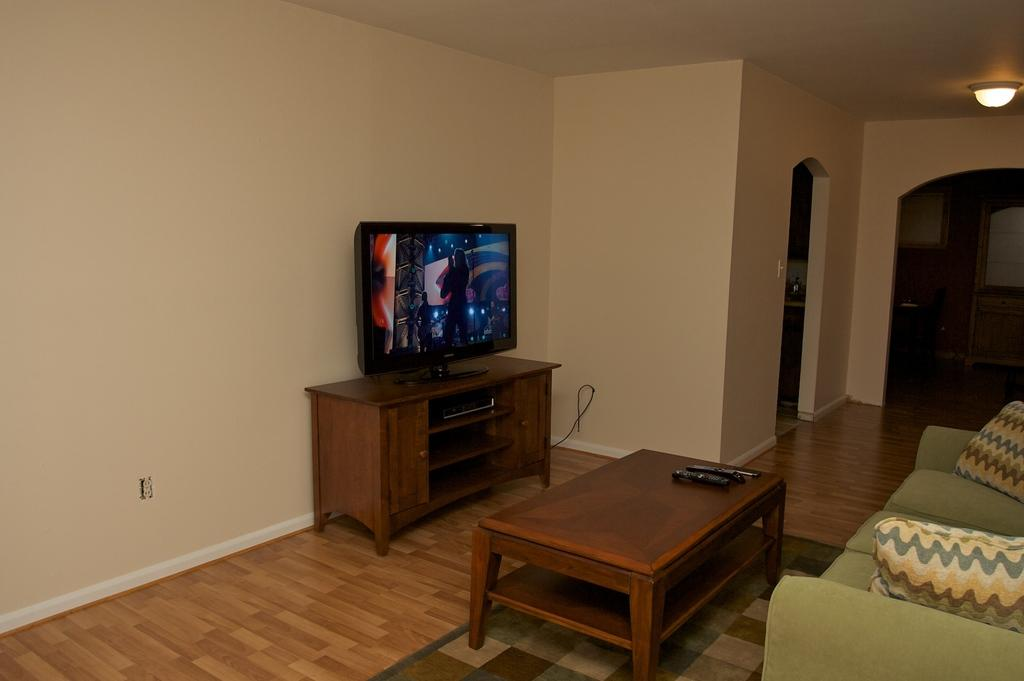What is located on the left side of the image? There is a wall on the left side of the image. What can be seen on the right side of the image? There is a sofa on the right side of the image. What is the source of light in the image? There is a light in the image. What is the main electronic device in the image? There is a TV in the middle of the image. Are there any ants crawling on the sofa in the image? There is no indication of ants in the image; it only shows a wall, a sofa, a light, and a TV. What type of collar is being worn by the TV in the image? There is no collar present in the image, as the main subjects are a wall, a sofa, a light, and a TV. 